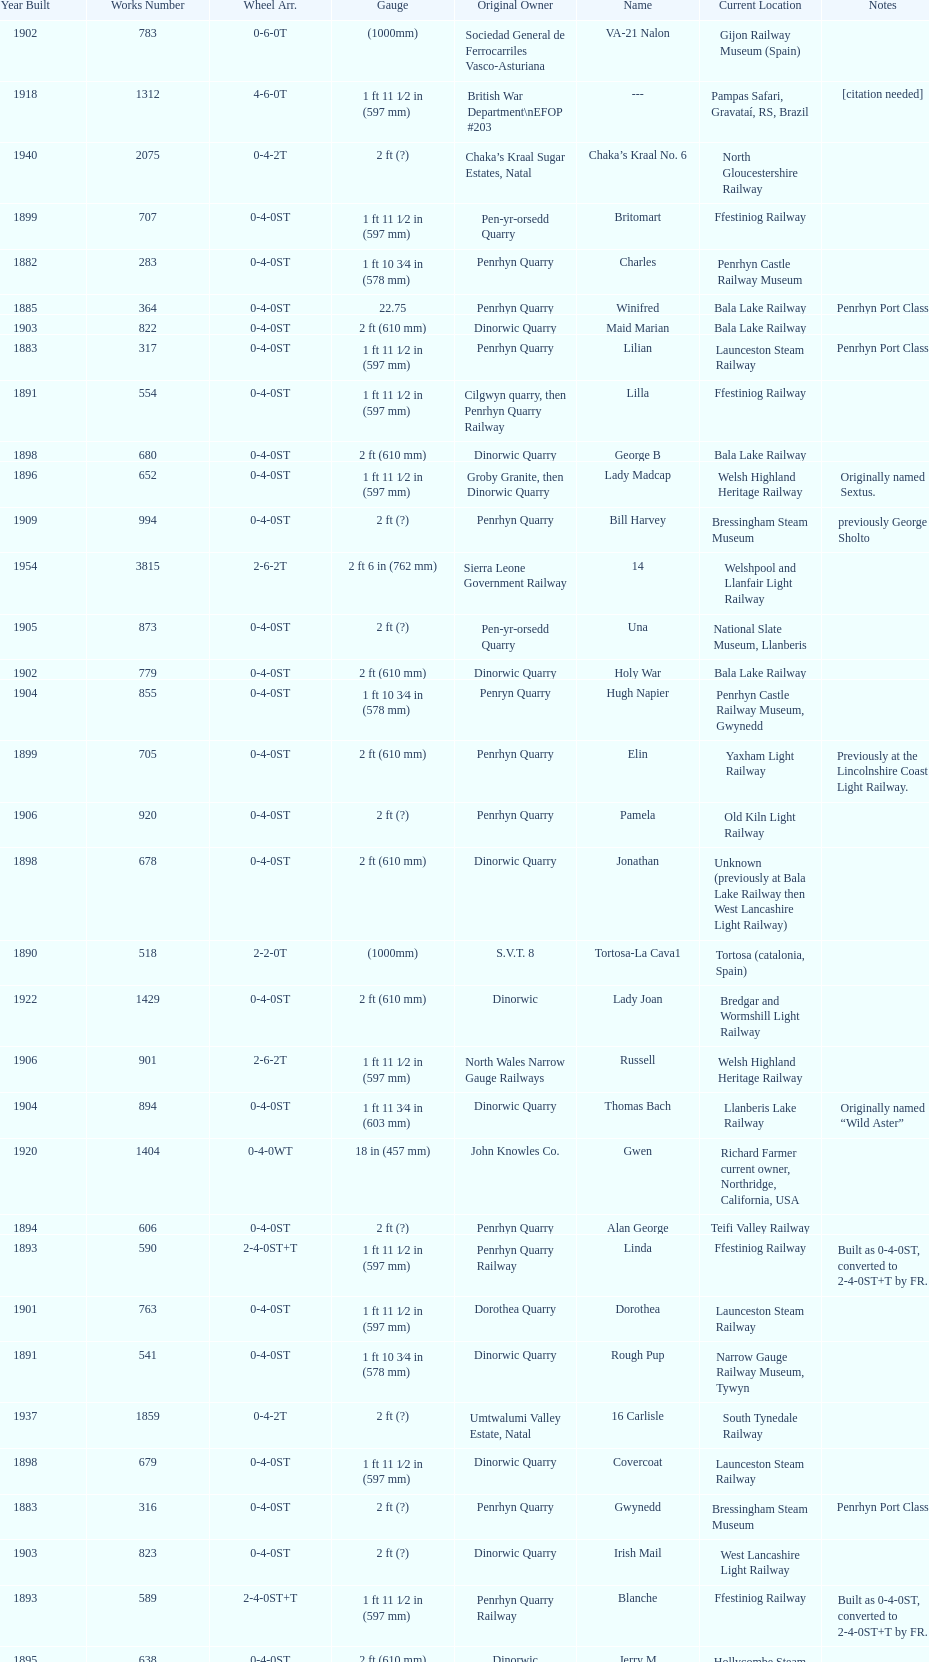Which original owner had the most locomotives? Penrhyn Quarry. 